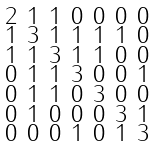Convert formula to latex. <formula><loc_0><loc_0><loc_500><loc_500>\begin{smallmatrix} 2 & 1 & 1 & 0 & 0 & 0 & 0 \\ 1 & 3 & 1 & 1 & 1 & 1 & 0 \\ 1 & 1 & 3 & 1 & 1 & 0 & 0 \\ 0 & 1 & 1 & 3 & 0 & 0 & 1 \\ 0 & 1 & 1 & 0 & 3 & 0 & 0 \\ 0 & 1 & 0 & 0 & 0 & 3 & 1 \\ 0 & 0 & 0 & 1 & 0 & 1 & 3 \end{smallmatrix}</formula> 